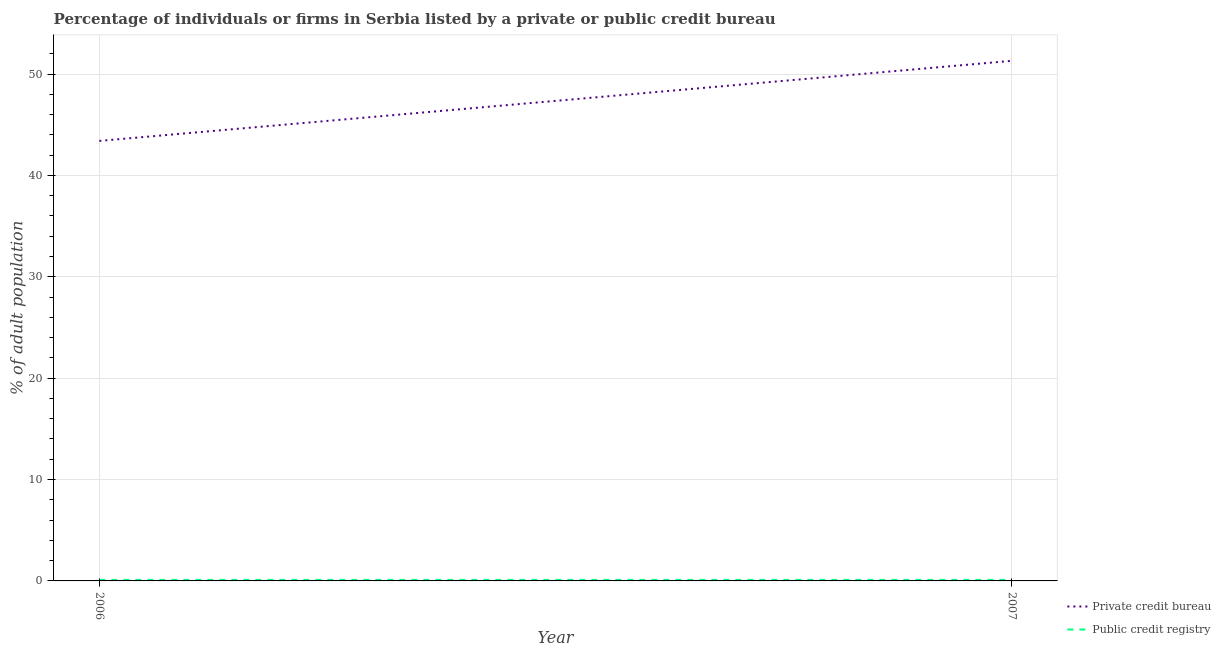What is the percentage of firms listed by private credit bureau in 2006?
Offer a very short reply. 43.4. Across all years, what is the maximum percentage of firms listed by private credit bureau?
Make the answer very short. 51.3. Across all years, what is the minimum percentage of firms listed by private credit bureau?
Give a very brief answer. 43.4. In which year was the percentage of firms listed by private credit bureau maximum?
Your answer should be compact. 2007. What is the difference between the percentage of firms listed by public credit bureau in 2006 and the percentage of firms listed by private credit bureau in 2007?
Offer a terse response. -51.2. What is the average percentage of firms listed by private credit bureau per year?
Your answer should be very brief. 47.35. In the year 2007, what is the difference between the percentage of firms listed by public credit bureau and percentage of firms listed by private credit bureau?
Make the answer very short. -51.2. What is the ratio of the percentage of firms listed by public credit bureau in 2006 to that in 2007?
Provide a short and direct response. 1. Is the percentage of firms listed by public credit bureau in 2006 less than that in 2007?
Your answer should be compact. No. Does the percentage of firms listed by public credit bureau monotonically increase over the years?
Ensure brevity in your answer.  No. How many lines are there?
Your answer should be very brief. 2. Does the graph contain any zero values?
Offer a terse response. No. Does the graph contain grids?
Offer a terse response. Yes. How are the legend labels stacked?
Offer a very short reply. Vertical. What is the title of the graph?
Your response must be concise. Percentage of individuals or firms in Serbia listed by a private or public credit bureau. Does "Domestic liabilities" appear as one of the legend labels in the graph?
Offer a very short reply. No. What is the label or title of the X-axis?
Your answer should be very brief. Year. What is the label or title of the Y-axis?
Provide a succinct answer. % of adult population. What is the % of adult population of Private credit bureau in 2006?
Ensure brevity in your answer.  43.4. What is the % of adult population of Public credit registry in 2006?
Provide a short and direct response. 0.1. What is the % of adult population in Private credit bureau in 2007?
Give a very brief answer. 51.3. Across all years, what is the maximum % of adult population in Private credit bureau?
Give a very brief answer. 51.3. Across all years, what is the maximum % of adult population in Public credit registry?
Ensure brevity in your answer.  0.1. Across all years, what is the minimum % of adult population in Private credit bureau?
Make the answer very short. 43.4. What is the total % of adult population of Private credit bureau in the graph?
Your response must be concise. 94.7. What is the difference between the % of adult population of Private credit bureau in 2006 and that in 2007?
Give a very brief answer. -7.9. What is the difference between the % of adult population of Public credit registry in 2006 and that in 2007?
Provide a succinct answer. 0. What is the difference between the % of adult population in Private credit bureau in 2006 and the % of adult population in Public credit registry in 2007?
Offer a very short reply. 43.3. What is the average % of adult population in Private credit bureau per year?
Provide a short and direct response. 47.35. What is the average % of adult population of Public credit registry per year?
Offer a very short reply. 0.1. In the year 2006, what is the difference between the % of adult population in Private credit bureau and % of adult population in Public credit registry?
Ensure brevity in your answer.  43.3. In the year 2007, what is the difference between the % of adult population of Private credit bureau and % of adult population of Public credit registry?
Provide a short and direct response. 51.2. What is the ratio of the % of adult population in Private credit bureau in 2006 to that in 2007?
Your response must be concise. 0.85. What is the ratio of the % of adult population of Public credit registry in 2006 to that in 2007?
Ensure brevity in your answer.  1. What is the difference between the highest and the second highest % of adult population in Private credit bureau?
Give a very brief answer. 7.9. 